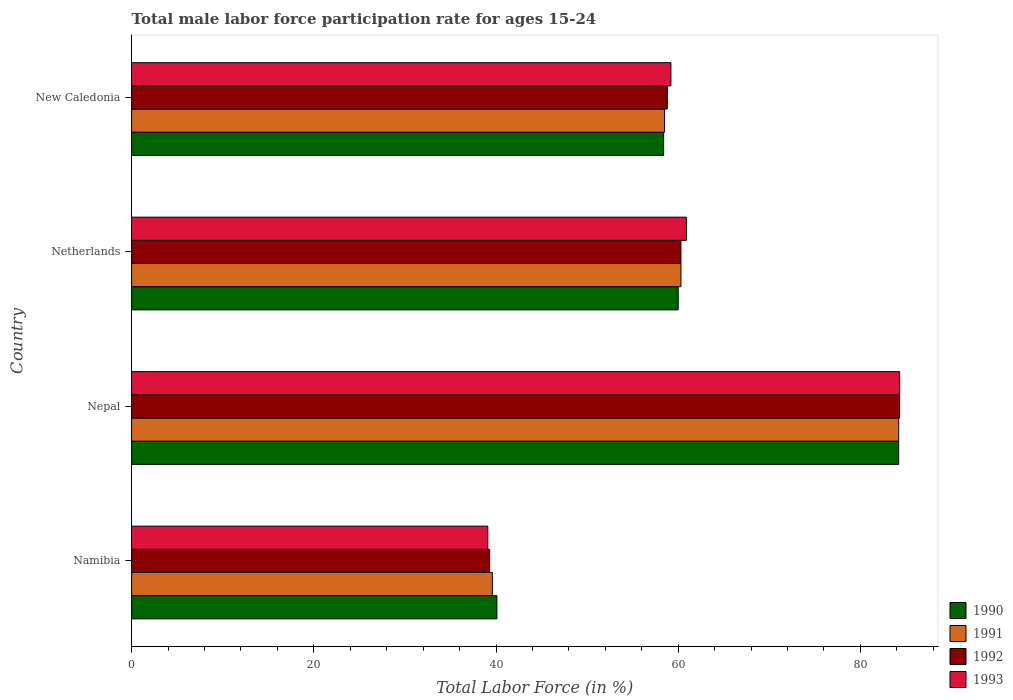How many different coloured bars are there?
Offer a very short reply. 4. How many groups of bars are there?
Your answer should be compact. 4. How many bars are there on the 4th tick from the top?
Ensure brevity in your answer.  4. What is the label of the 2nd group of bars from the top?
Ensure brevity in your answer.  Netherlands. What is the male labor force participation rate in 1990 in Nepal?
Offer a very short reply. 84.2. Across all countries, what is the maximum male labor force participation rate in 1992?
Offer a terse response. 84.3. Across all countries, what is the minimum male labor force participation rate in 1990?
Offer a terse response. 40.1. In which country was the male labor force participation rate in 1991 maximum?
Ensure brevity in your answer.  Nepal. In which country was the male labor force participation rate in 1990 minimum?
Your response must be concise. Namibia. What is the total male labor force participation rate in 1991 in the graph?
Make the answer very short. 242.6. What is the difference between the male labor force participation rate in 1990 in Namibia and that in Netherlands?
Keep it short and to the point. -19.9. What is the difference between the male labor force participation rate in 1990 in Namibia and the male labor force participation rate in 1992 in New Caledonia?
Your response must be concise. -18.7. What is the average male labor force participation rate in 1990 per country?
Offer a very short reply. 60.67. What is the difference between the male labor force participation rate in 1990 and male labor force participation rate in 1991 in New Caledonia?
Provide a short and direct response. -0.1. In how many countries, is the male labor force participation rate in 1992 greater than 68 %?
Your response must be concise. 1. What is the ratio of the male labor force participation rate in 1990 in Namibia to that in New Caledonia?
Your answer should be compact. 0.69. Is the male labor force participation rate in 1990 in Namibia less than that in Netherlands?
Give a very brief answer. Yes. What is the difference between the highest and the second highest male labor force participation rate in 1991?
Offer a very short reply. 23.9. What is the difference between the highest and the lowest male labor force participation rate in 1993?
Keep it short and to the point. 45.2. In how many countries, is the male labor force participation rate in 1991 greater than the average male labor force participation rate in 1991 taken over all countries?
Your answer should be compact. 1. Is it the case that in every country, the sum of the male labor force participation rate in 1990 and male labor force participation rate in 1992 is greater than the sum of male labor force participation rate in 1993 and male labor force participation rate in 1991?
Give a very brief answer. No. What does the 1st bar from the top in New Caledonia represents?
Provide a succinct answer. 1993. What does the 1st bar from the bottom in Nepal represents?
Provide a short and direct response. 1990. Is it the case that in every country, the sum of the male labor force participation rate in 1990 and male labor force participation rate in 1991 is greater than the male labor force participation rate in 1993?
Your answer should be very brief. Yes. How many bars are there?
Ensure brevity in your answer.  16. Are all the bars in the graph horizontal?
Make the answer very short. Yes. How many countries are there in the graph?
Your answer should be compact. 4. What is the difference between two consecutive major ticks on the X-axis?
Ensure brevity in your answer.  20. Does the graph contain grids?
Provide a short and direct response. No. How are the legend labels stacked?
Make the answer very short. Vertical. What is the title of the graph?
Ensure brevity in your answer.  Total male labor force participation rate for ages 15-24. What is the label or title of the X-axis?
Your response must be concise. Total Labor Force (in %). What is the label or title of the Y-axis?
Keep it short and to the point. Country. What is the Total Labor Force (in %) in 1990 in Namibia?
Your answer should be very brief. 40.1. What is the Total Labor Force (in %) of 1991 in Namibia?
Your answer should be very brief. 39.6. What is the Total Labor Force (in %) of 1992 in Namibia?
Your response must be concise. 39.3. What is the Total Labor Force (in %) in 1993 in Namibia?
Provide a short and direct response. 39.1. What is the Total Labor Force (in %) in 1990 in Nepal?
Provide a succinct answer. 84.2. What is the Total Labor Force (in %) in 1991 in Nepal?
Give a very brief answer. 84.2. What is the Total Labor Force (in %) of 1992 in Nepal?
Your answer should be compact. 84.3. What is the Total Labor Force (in %) in 1993 in Nepal?
Ensure brevity in your answer.  84.3. What is the Total Labor Force (in %) in 1990 in Netherlands?
Your response must be concise. 60. What is the Total Labor Force (in %) of 1991 in Netherlands?
Provide a succinct answer. 60.3. What is the Total Labor Force (in %) of 1992 in Netherlands?
Your answer should be very brief. 60.3. What is the Total Labor Force (in %) of 1993 in Netherlands?
Your answer should be compact. 60.9. What is the Total Labor Force (in %) in 1990 in New Caledonia?
Your answer should be very brief. 58.4. What is the Total Labor Force (in %) of 1991 in New Caledonia?
Give a very brief answer. 58.5. What is the Total Labor Force (in %) in 1992 in New Caledonia?
Offer a terse response. 58.8. What is the Total Labor Force (in %) of 1993 in New Caledonia?
Provide a succinct answer. 59.2. Across all countries, what is the maximum Total Labor Force (in %) of 1990?
Ensure brevity in your answer.  84.2. Across all countries, what is the maximum Total Labor Force (in %) of 1991?
Offer a terse response. 84.2. Across all countries, what is the maximum Total Labor Force (in %) of 1992?
Make the answer very short. 84.3. Across all countries, what is the maximum Total Labor Force (in %) of 1993?
Your answer should be very brief. 84.3. Across all countries, what is the minimum Total Labor Force (in %) in 1990?
Offer a terse response. 40.1. Across all countries, what is the minimum Total Labor Force (in %) in 1991?
Your response must be concise. 39.6. Across all countries, what is the minimum Total Labor Force (in %) in 1992?
Your response must be concise. 39.3. Across all countries, what is the minimum Total Labor Force (in %) in 1993?
Your response must be concise. 39.1. What is the total Total Labor Force (in %) in 1990 in the graph?
Offer a terse response. 242.7. What is the total Total Labor Force (in %) of 1991 in the graph?
Make the answer very short. 242.6. What is the total Total Labor Force (in %) in 1992 in the graph?
Ensure brevity in your answer.  242.7. What is the total Total Labor Force (in %) of 1993 in the graph?
Give a very brief answer. 243.5. What is the difference between the Total Labor Force (in %) of 1990 in Namibia and that in Nepal?
Your response must be concise. -44.1. What is the difference between the Total Labor Force (in %) in 1991 in Namibia and that in Nepal?
Provide a succinct answer. -44.6. What is the difference between the Total Labor Force (in %) in 1992 in Namibia and that in Nepal?
Offer a very short reply. -45. What is the difference between the Total Labor Force (in %) in 1993 in Namibia and that in Nepal?
Provide a short and direct response. -45.2. What is the difference between the Total Labor Force (in %) in 1990 in Namibia and that in Netherlands?
Make the answer very short. -19.9. What is the difference between the Total Labor Force (in %) of 1991 in Namibia and that in Netherlands?
Offer a very short reply. -20.7. What is the difference between the Total Labor Force (in %) in 1992 in Namibia and that in Netherlands?
Provide a short and direct response. -21. What is the difference between the Total Labor Force (in %) of 1993 in Namibia and that in Netherlands?
Your response must be concise. -21.8. What is the difference between the Total Labor Force (in %) in 1990 in Namibia and that in New Caledonia?
Ensure brevity in your answer.  -18.3. What is the difference between the Total Labor Force (in %) of 1991 in Namibia and that in New Caledonia?
Provide a succinct answer. -18.9. What is the difference between the Total Labor Force (in %) in 1992 in Namibia and that in New Caledonia?
Keep it short and to the point. -19.5. What is the difference between the Total Labor Force (in %) in 1993 in Namibia and that in New Caledonia?
Ensure brevity in your answer.  -20.1. What is the difference between the Total Labor Force (in %) in 1990 in Nepal and that in Netherlands?
Ensure brevity in your answer.  24.2. What is the difference between the Total Labor Force (in %) of 1991 in Nepal and that in Netherlands?
Your response must be concise. 23.9. What is the difference between the Total Labor Force (in %) in 1992 in Nepal and that in Netherlands?
Keep it short and to the point. 24. What is the difference between the Total Labor Force (in %) in 1993 in Nepal and that in Netherlands?
Keep it short and to the point. 23.4. What is the difference between the Total Labor Force (in %) in 1990 in Nepal and that in New Caledonia?
Offer a very short reply. 25.8. What is the difference between the Total Labor Force (in %) in 1991 in Nepal and that in New Caledonia?
Offer a very short reply. 25.7. What is the difference between the Total Labor Force (in %) in 1992 in Nepal and that in New Caledonia?
Give a very brief answer. 25.5. What is the difference between the Total Labor Force (in %) in 1993 in Nepal and that in New Caledonia?
Provide a short and direct response. 25.1. What is the difference between the Total Labor Force (in %) of 1990 in Netherlands and that in New Caledonia?
Give a very brief answer. 1.6. What is the difference between the Total Labor Force (in %) of 1991 in Netherlands and that in New Caledonia?
Ensure brevity in your answer.  1.8. What is the difference between the Total Labor Force (in %) in 1992 in Netherlands and that in New Caledonia?
Offer a terse response. 1.5. What is the difference between the Total Labor Force (in %) in 1990 in Namibia and the Total Labor Force (in %) in 1991 in Nepal?
Your response must be concise. -44.1. What is the difference between the Total Labor Force (in %) of 1990 in Namibia and the Total Labor Force (in %) of 1992 in Nepal?
Your response must be concise. -44.2. What is the difference between the Total Labor Force (in %) in 1990 in Namibia and the Total Labor Force (in %) in 1993 in Nepal?
Give a very brief answer. -44.2. What is the difference between the Total Labor Force (in %) in 1991 in Namibia and the Total Labor Force (in %) in 1992 in Nepal?
Provide a succinct answer. -44.7. What is the difference between the Total Labor Force (in %) of 1991 in Namibia and the Total Labor Force (in %) of 1993 in Nepal?
Offer a terse response. -44.7. What is the difference between the Total Labor Force (in %) of 1992 in Namibia and the Total Labor Force (in %) of 1993 in Nepal?
Your answer should be compact. -45. What is the difference between the Total Labor Force (in %) in 1990 in Namibia and the Total Labor Force (in %) in 1991 in Netherlands?
Give a very brief answer. -20.2. What is the difference between the Total Labor Force (in %) in 1990 in Namibia and the Total Labor Force (in %) in 1992 in Netherlands?
Offer a terse response. -20.2. What is the difference between the Total Labor Force (in %) in 1990 in Namibia and the Total Labor Force (in %) in 1993 in Netherlands?
Offer a terse response. -20.8. What is the difference between the Total Labor Force (in %) in 1991 in Namibia and the Total Labor Force (in %) in 1992 in Netherlands?
Offer a terse response. -20.7. What is the difference between the Total Labor Force (in %) in 1991 in Namibia and the Total Labor Force (in %) in 1993 in Netherlands?
Your answer should be compact. -21.3. What is the difference between the Total Labor Force (in %) in 1992 in Namibia and the Total Labor Force (in %) in 1993 in Netherlands?
Offer a very short reply. -21.6. What is the difference between the Total Labor Force (in %) in 1990 in Namibia and the Total Labor Force (in %) in 1991 in New Caledonia?
Offer a very short reply. -18.4. What is the difference between the Total Labor Force (in %) of 1990 in Namibia and the Total Labor Force (in %) of 1992 in New Caledonia?
Offer a very short reply. -18.7. What is the difference between the Total Labor Force (in %) of 1990 in Namibia and the Total Labor Force (in %) of 1993 in New Caledonia?
Your response must be concise. -19.1. What is the difference between the Total Labor Force (in %) in 1991 in Namibia and the Total Labor Force (in %) in 1992 in New Caledonia?
Ensure brevity in your answer.  -19.2. What is the difference between the Total Labor Force (in %) of 1991 in Namibia and the Total Labor Force (in %) of 1993 in New Caledonia?
Ensure brevity in your answer.  -19.6. What is the difference between the Total Labor Force (in %) in 1992 in Namibia and the Total Labor Force (in %) in 1993 in New Caledonia?
Provide a short and direct response. -19.9. What is the difference between the Total Labor Force (in %) in 1990 in Nepal and the Total Labor Force (in %) in 1991 in Netherlands?
Make the answer very short. 23.9. What is the difference between the Total Labor Force (in %) in 1990 in Nepal and the Total Labor Force (in %) in 1992 in Netherlands?
Make the answer very short. 23.9. What is the difference between the Total Labor Force (in %) of 1990 in Nepal and the Total Labor Force (in %) of 1993 in Netherlands?
Keep it short and to the point. 23.3. What is the difference between the Total Labor Force (in %) of 1991 in Nepal and the Total Labor Force (in %) of 1992 in Netherlands?
Offer a terse response. 23.9. What is the difference between the Total Labor Force (in %) in 1991 in Nepal and the Total Labor Force (in %) in 1993 in Netherlands?
Keep it short and to the point. 23.3. What is the difference between the Total Labor Force (in %) in 1992 in Nepal and the Total Labor Force (in %) in 1993 in Netherlands?
Provide a succinct answer. 23.4. What is the difference between the Total Labor Force (in %) in 1990 in Nepal and the Total Labor Force (in %) in 1991 in New Caledonia?
Your response must be concise. 25.7. What is the difference between the Total Labor Force (in %) of 1990 in Nepal and the Total Labor Force (in %) of 1992 in New Caledonia?
Your answer should be very brief. 25.4. What is the difference between the Total Labor Force (in %) of 1990 in Nepal and the Total Labor Force (in %) of 1993 in New Caledonia?
Offer a very short reply. 25. What is the difference between the Total Labor Force (in %) in 1991 in Nepal and the Total Labor Force (in %) in 1992 in New Caledonia?
Keep it short and to the point. 25.4. What is the difference between the Total Labor Force (in %) of 1992 in Nepal and the Total Labor Force (in %) of 1993 in New Caledonia?
Give a very brief answer. 25.1. What is the difference between the Total Labor Force (in %) in 1990 in Netherlands and the Total Labor Force (in %) in 1991 in New Caledonia?
Ensure brevity in your answer.  1.5. What is the difference between the Total Labor Force (in %) of 1990 in Netherlands and the Total Labor Force (in %) of 1992 in New Caledonia?
Your answer should be very brief. 1.2. What is the difference between the Total Labor Force (in %) in 1990 in Netherlands and the Total Labor Force (in %) in 1993 in New Caledonia?
Your answer should be compact. 0.8. What is the difference between the Total Labor Force (in %) of 1991 in Netherlands and the Total Labor Force (in %) of 1992 in New Caledonia?
Provide a short and direct response. 1.5. What is the difference between the Total Labor Force (in %) of 1992 in Netherlands and the Total Labor Force (in %) of 1993 in New Caledonia?
Your response must be concise. 1.1. What is the average Total Labor Force (in %) in 1990 per country?
Your response must be concise. 60.67. What is the average Total Labor Force (in %) of 1991 per country?
Your answer should be very brief. 60.65. What is the average Total Labor Force (in %) of 1992 per country?
Make the answer very short. 60.67. What is the average Total Labor Force (in %) of 1993 per country?
Your answer should be very brief. 60.88. What is the difference between the Total Labor Force (in %) in 1990 and Total Labor Force (in %) in 1991 in Namibia?
Ensure brevity in your answer.  0.5. What is the difference between the Total Labor Force (in %) in 1990 and Total Labor Force (in %) in 1993 in Namibia?
Provide a succinct answer. 1. What is the difference between the Total Labor Force (in %) in 1991 and Total Labor Force (in %) in 1993 in Namibia?
Give a very brief answer. 0.5. What is the difference between the Total Labor Force (in %) of 1992 and Total Labor Force (in %) of 1993 in Namibia?
Your response must be concise. 0.2. What is the difference between the Total Labor Force (in %) in 1991 and Total Labor Force (in %) in 1993 in Nepal?
Offer a very short reply. -0.1. What is the difference between the Total Labor Force (in %) in 1990 and Total Labor Force (in %) in 1991 in Netherlands?
Your answer should be compact. -0.3. What is the difference between the Total Labor Force (in %) of 1990 and Total Labor Force (in %) of 1992 in Netherlands?
Keep it short and to the point. -0.3. What is the difference between the Total Labor Force (in %) of 1991 and Total Labor Force (in %) of 1992 in Netherlands?
Offer a terse response. 0. What is the difference between the Total Labor Force (in %) in 1991 and Total Labor Force (in %) in 1993 in Netherlands?
Offer a very short reply. -0.6. What is the difference between the Total Labor Force (in %) in 1992 and Total Labor Force (in %) in 1993 in Netherlands?
Your response must be concise. -0.6. What is the difference between the Total Labor Force (in %) in 1990 and Total Labor Force (in %) in 1992 in New Caledonia?
Give a very brief answer. -0.4. What is the difference between the Total Labor Force (in %) in 1990 and Total Labor Force (in %) in 1993 in New Caledonia?
Keep it short and to the point. -0.8. What is the difference between the Total Labor Force (in %) of 1992 and Total Labor Force (in %) of 1993 in New Caledonia?
Provide a succinct answer. -0.4. What is the ratio of the Total Labor Force (in %) of 1990 in Namibia to that in Nepal?
Provide a short and direct response. 0.48. What is the ratio of the Total Labor Force (in %) of 1991 in Namibia to that in Nepal?
Your response must be concise. 0.47. What is the ratio of the Total Labor Force (in %) in 1992 in Namibia to that in Nepal?
Give a very brief answer. 0.47. What is the ratio of the Total Labor Force (in %) of 1993 in Namibia to that in Nepal?
Offer a terse response. 0.46. What is the ratio of the Total Labor Force (in %) of 1990 in Namibia to that in Netherlands?
Give a very brief answer. 0.67. What is the ratio of the Total Labor Force (in %) in 1991 in Namibia to that in Netherlands?
Your answer should be compact. 0.66. What is the ratio of the Total Labor Force (in %) of 1992 in Namibia to that in Netherlands?
Give a very brief answer. 0.65. What is the ratio of the Total Labor Force (in %) of 1993 in Namibia to that in Netherlands?
Keep it short and to the point. 0.64. What is the ratio of the Total Labor Force (in %) in 1990 in Namibia to that in New Caledonia?
Ensure brevity in your answer.  0.69. What is the ratio of the Total Labor Force (in %) in 1991 in Namibia to that in New Caledonia?
Make the answer very short. 0.68. What is the ratio of the Total Labor Force (in %) of 1992 in Namibia to that in New Caledonia?
Ensure brevity in your answer.  0.67. What is the ratio of the Total Labor Force (in %) of 1993 in Namibia to that in New Caledonia?
Ensure brevity in your answer.  0.66. What is the ratio of the Total Labor Force (in %) in 1990 in Nepal to that in Netherlands?
Your answer should be very brief. 1.4. What is the ratio of the Total Labor Force (in %) of 1991 in Nepal to that in Netherlands?
Your answer should be very brief. 1.4. What is the ratio of the Total Labor Force (in %) in 1992 in Nepal to that in Netherlands?
Keep it short and to the point. 1.4. What is the ratio of the Total Labor Force (in %) of 1993 in Nepal to that in Netherlands?
Provide a short and direct response. 1.38. What is the ratio of the Total Labor Force (in %) of 1990 in Nepal to that in New Caledonia?
Offer a terse response. 1.44. What is the ratio of the Total Labor Force (in %) of 1991 in Nepal to that in New Caledonia?
Give a very brief answer. 1.44. What is the ratio of the Total Labor Force (in %) of 1992 in Nepal to that in New Caledonia?
Ensure brevity in your answer.  1.43. What is the ratio of the Total Labor Force (in %) of 1993 in Nepal to that in New Caledonia?
Offer a terse response. 1.42. What is the ratio of the Total Labor Force (in %) in 1990 in Netherlands to that in New Caledonia?
Provide a short and direct response. 1.03. What is the ratio of the Total Labor Force (in %) of 1991 in Netherlands to that in New Caledonia?
Offer a terse response. 1.03. What is the ratio of the Total Labor Force (in %) in 1992 in Netherlands to that in New Caledonia?
Your answer should be compact. 1.03. What is the ratio of the Total Labor Force (in %) in 1993 in Netherlands to that in New Caledonia?
Ensure brevity in your answer.  1.03. What is the difference between the highest and the second highest Total Labor Force (in %) in 1990?
Provide a succinct answer. 24.2. What is the difference between the highest and the second highest Total Labor Force (in %) in 1991?
Provide a short and direct response. 23.9. What is the difference between the highest and the second highest Total Labor Force (in %) of 1993?
Your response must be concise. 23.4. What is the difference between the highest and the lowest Total Labor Force (in %) of 1990?
Provide a short and direct response. 44.1. What is the difference between the highest and the lowest Total Labor Force (in %) of 1991?
Make the answer very short. 44.6. What is the difference between the highest and the lowest Total Labor Force (in %) in 1992?
Your answer should be compact. 45. What is the difference between the highest and the lowest Total Labor Force (in %) in 1993?
Your answer should be compact. 45.2. 